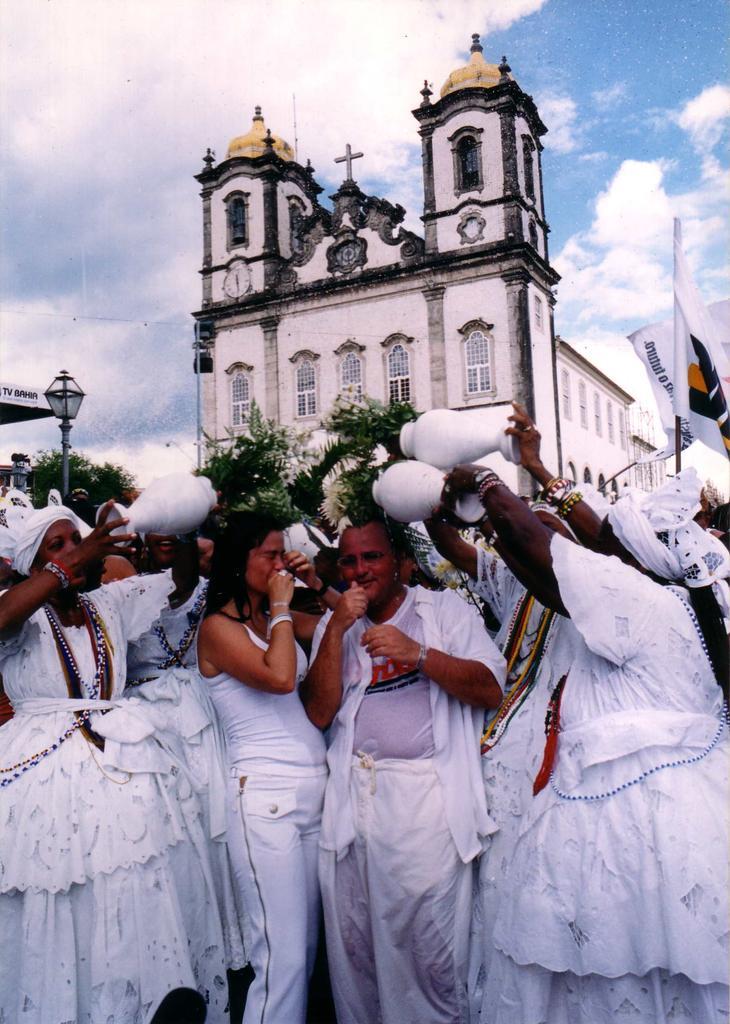Can you describe this image briefly? In this image I can see at the bottom a group of people are there, they wear white color dresses. At the top it looks like a church and there is the sky. 